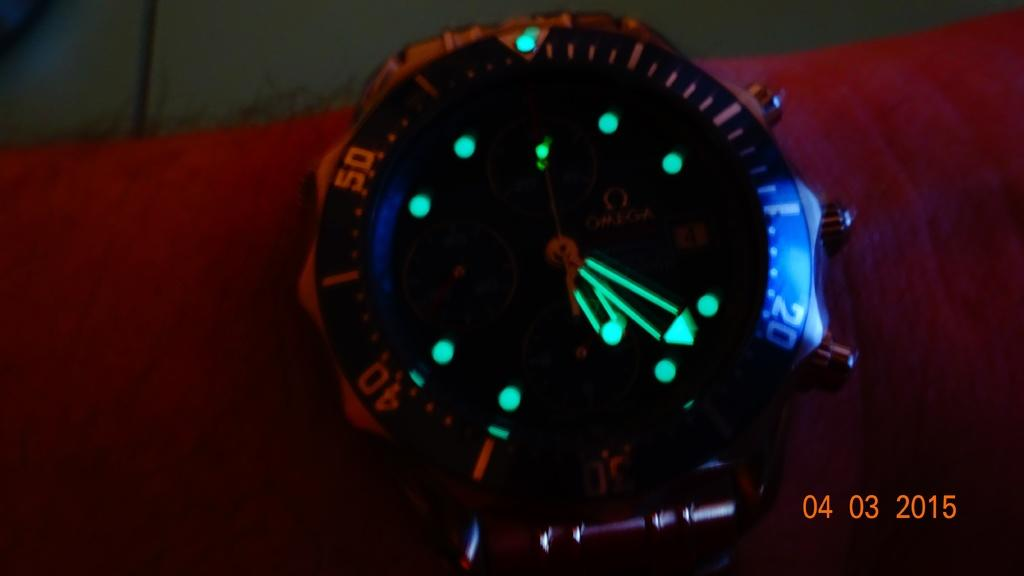<image>
Write a terse but informative summary of the picture. a glow in the dark watch face with a date stamp of 04 03 2015 